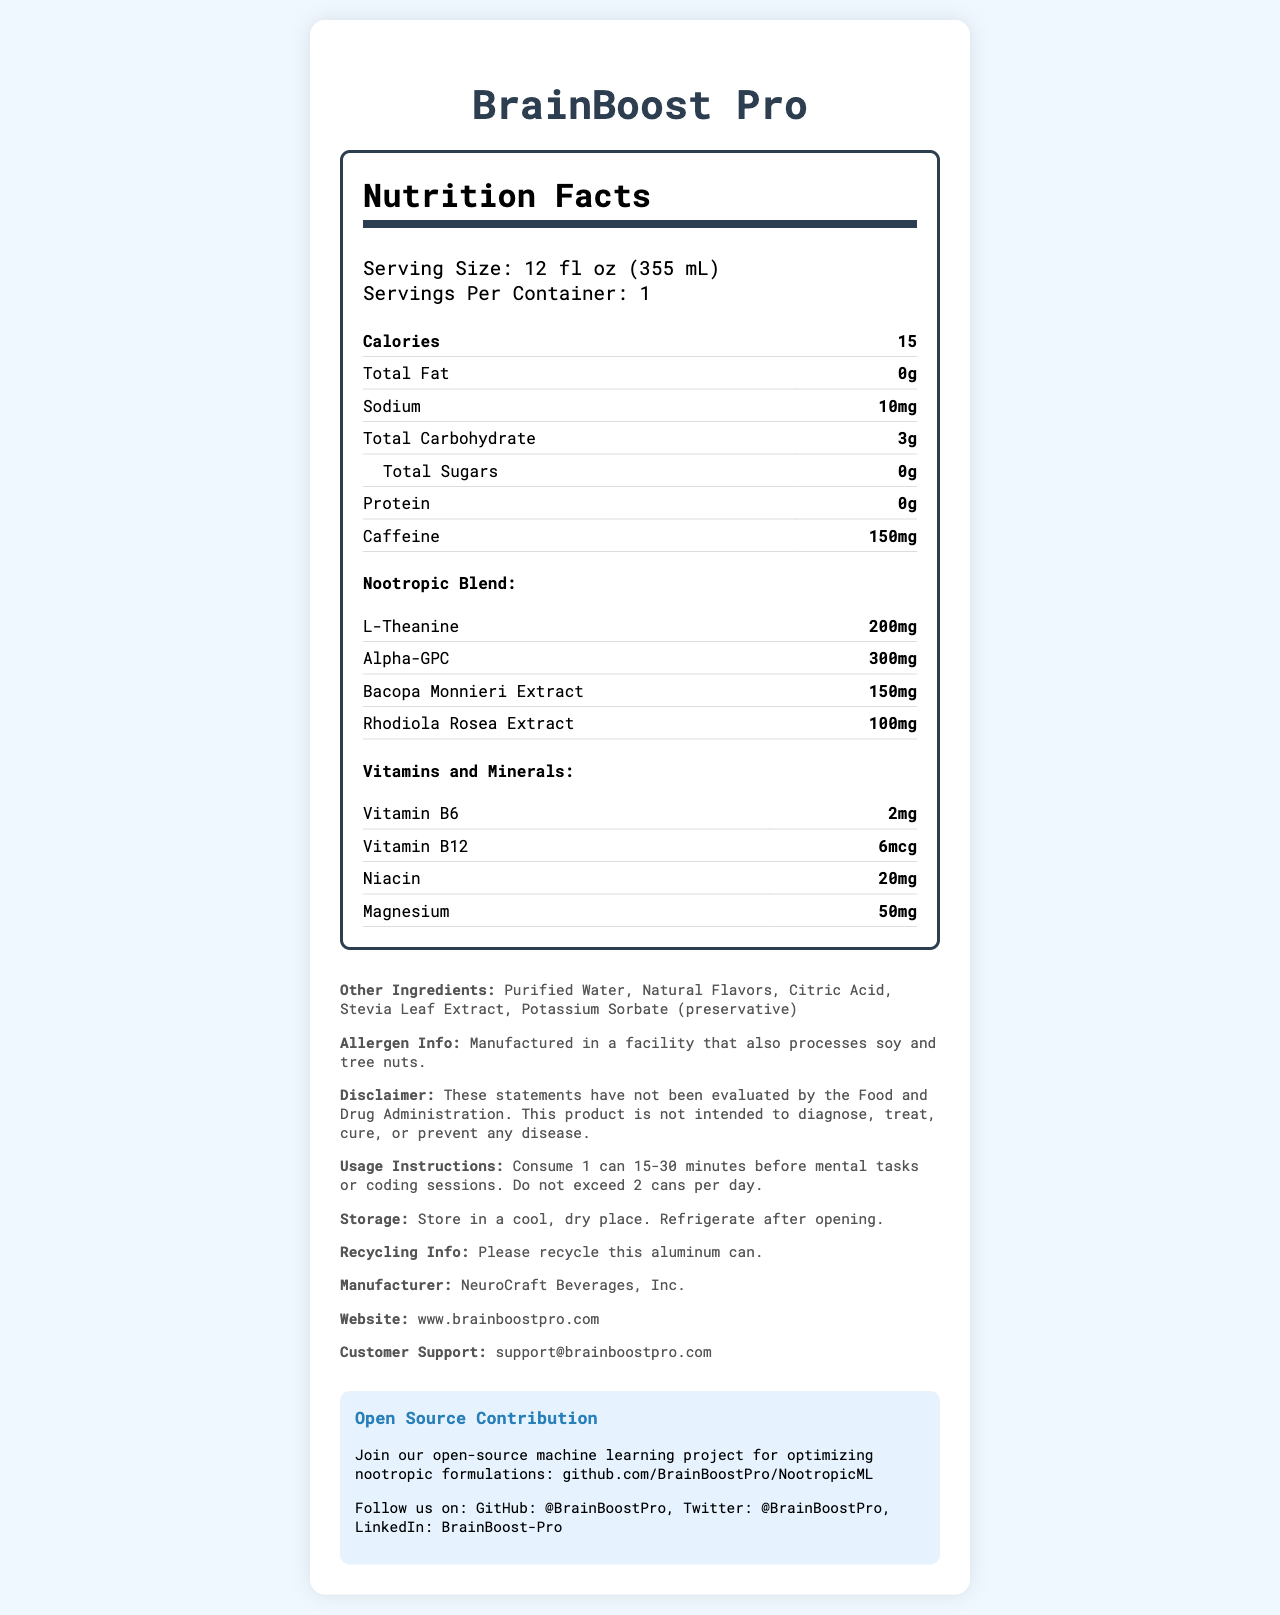What is the serving size of BrainBoost Pro? The serving size is clearly stated as "12 fl oz (355 mL)" in the "Serving Size" section.
Answer: 12 fl oz (355 mL) How many calories are in one serving of BrainBoost Pro? The document lists the number of calories per serving as 15.
Answer: 15 What are three ingredients in the nootropic blend of BrainBoost Pro? The nootropic blend section lists these ingredients: L-Theanine, Alpha-GPC, Bacopa Monnieri Extract, and Rhodiola Rosea Extract.
Answer: L-Theanine, Alpha-GPC, Bacopa Monnieri Extract What is the caffeine content in one serving of BrainBoost Pro? The caffeine content per serving is given as 150mg in the document.
Answer: 150mg What vitamins and minerals does BrainBoost Pro contain? The vitamins and minerals section lists Vitamin B6 (2mg), Vitamin B12 (6mcg), Niacin (20mg), and Magnesium (50mg).
Answer: Vitamin B6, Vitamin B12, Niacin, Magnesium How many servings are in one container of BrainBoost Pro? A. 1 B. 2 C. 3 The document clearly states that there is 1 serving per container.
Answer: A Which ingredient is used as a preservative in BrainBoost Pro? A. Stevia Leaf Extract B. Potassium Sorbate C. Natural Flavors The other ingredients section lists Potassium Sorbate explicitly as a preservative.
Answer: B Is BrainBoost Pro manufactured in a facility that processes allergens? The allergen information specifies that it is manufactured in a facility that also processes soy and tree nuts.
Answer: Yes Summarize the main idea of the document. The document is a comprehensive nutritional label for BrainBoost Pro, featuring key nutritional data and additional details that could inform potential users about its composition and how to use it safely.
Answer: The document provides detailed nutrition facts and ingredients for BrainBoost Pro, a functional beverage with nootropic ingredients and caffeine. It includes serving size, calorie count, vitamins, and minerals, as well as additional information such as usage instructions, storage recommendations, allergen info, and open-source contribution details. Which company's website can you visit for more information about BrainBoost Pro? The website for NeuroCraft Beverages, Inc., the manufacturer of BrainBoost Pro, is listed as www.brainboostpro.com.
Answer: www.brainboostpro.com How much L-Theanine is in each serving of BrainBoost Pro? The document specifies that there is 200mg of L-Theanine in each serving as part of the nootropic blend.
Answer: 200mg Can you determine the specific flavor of BrainBoost Pro from the document? The document mentions "Natural Flavors" but does not specify the exact flavor(s) used in BrainBoost Pro.
Answer: No What is the recommended maximum daily intake for BrainBoost Pro? A. 1 can B. 2 cans C. 3 cans The usage instructions recommend not exceeding 2 cans per day.
Answer: B Who is the manufacturer of BrainBoost Pro? The document lists NeuroCraft Beverages, Inc. as the manufacturer.
Answer: NeuroCraft Beverages, Inc. 